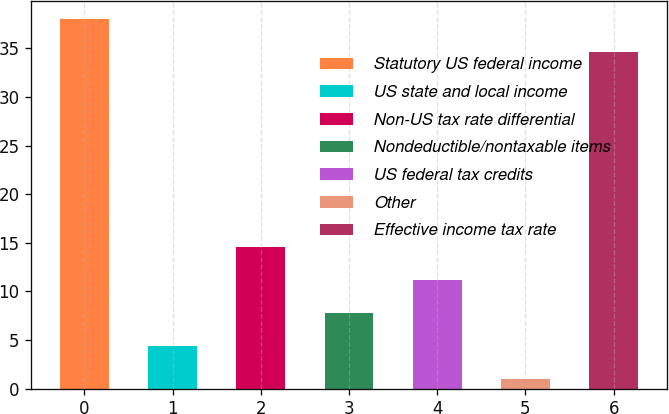Convert chart. <chart><loc_0><loc_0><loc_500><loc_500><bar_chart><fcel>Statutory US federal income<fcel>US state and local income<fcel>Non-US tax rate differential<fcel>Nondeductible/nontaxable items<fcel>US federal tax credits<fcel>Other<fcel>Effective income tax rate<nl><fcel>38<fcel>4.4<fcel>14.6<fcel>7.8<fcel>11.2<fcel>1<fcel>34.6<nl></chart> 